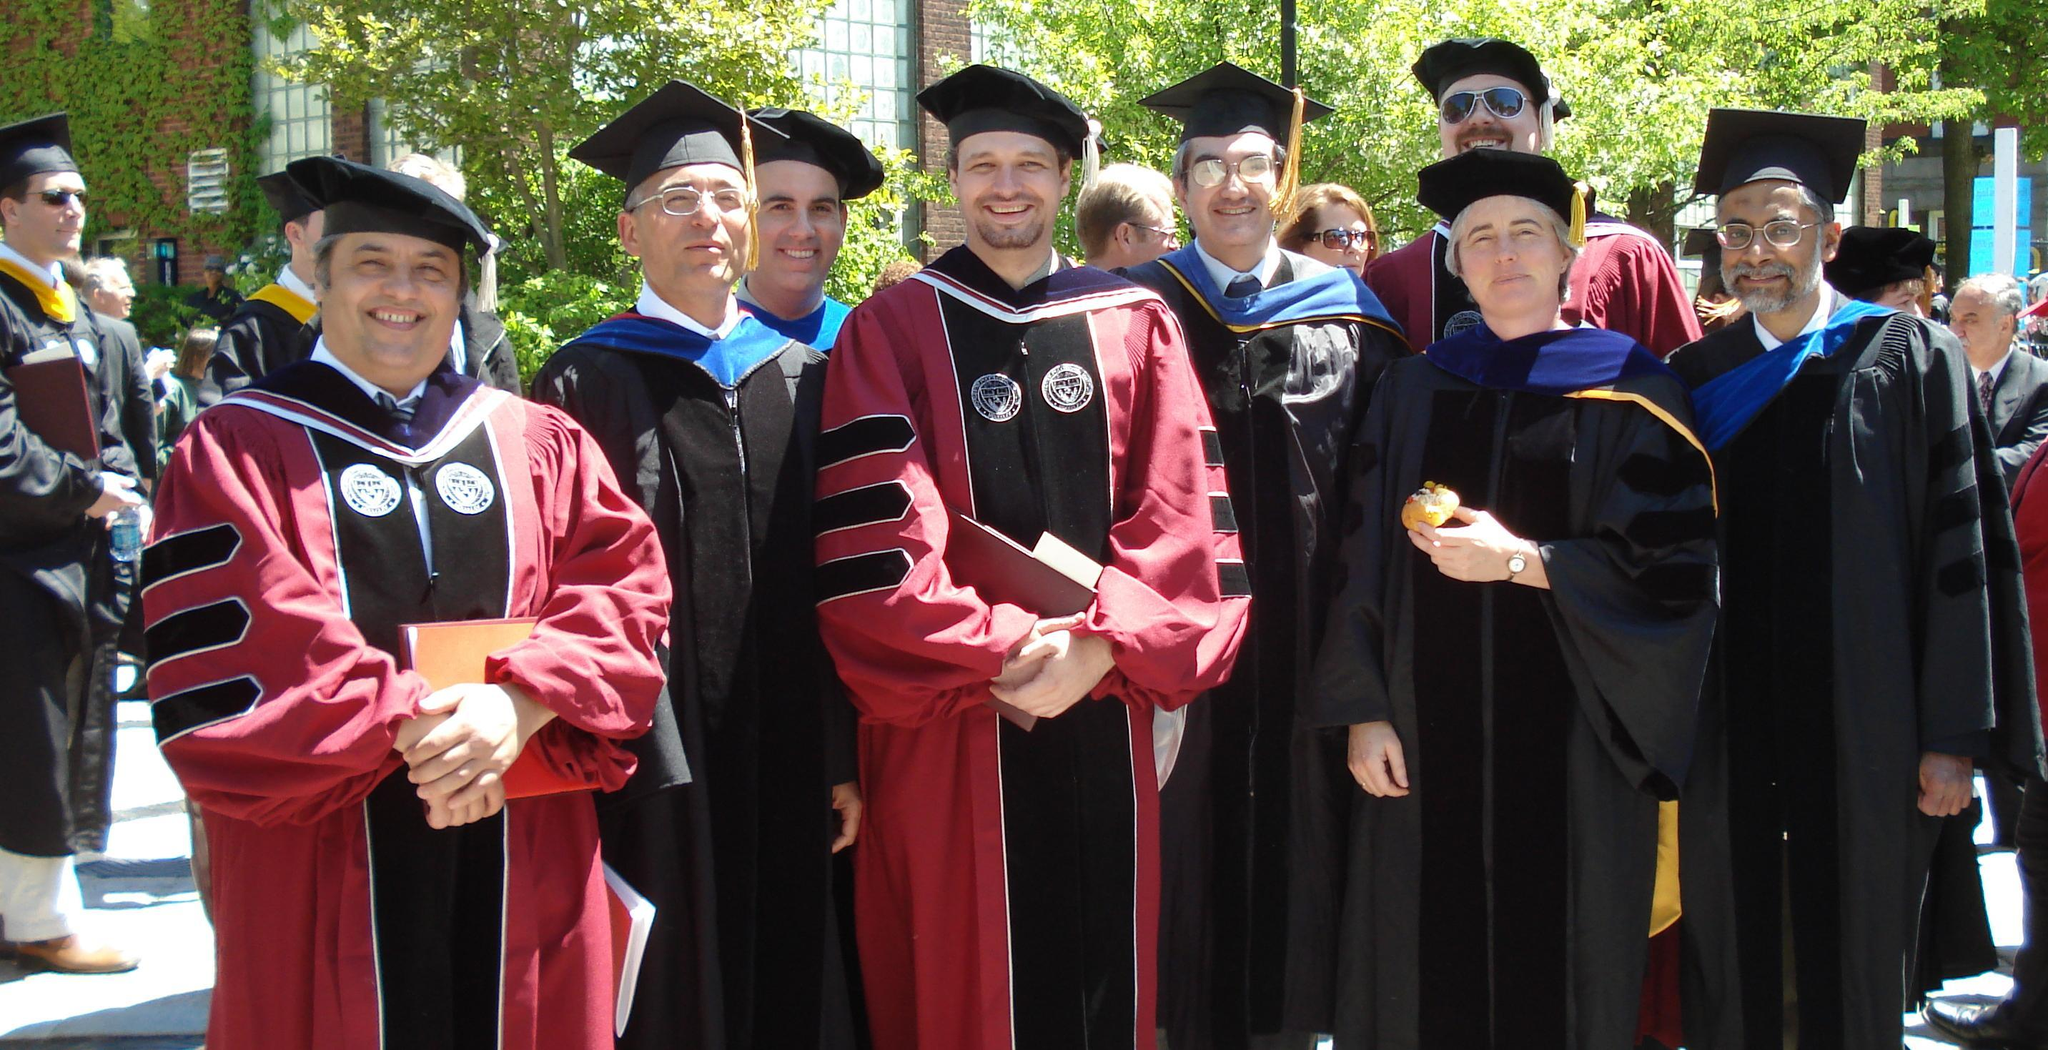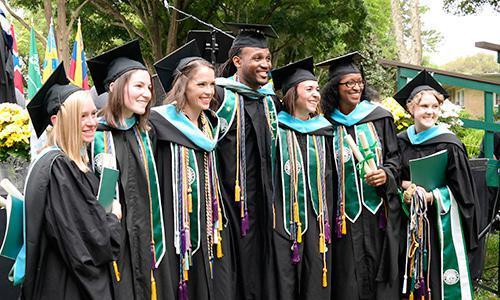The first image is the image on the left, the second image is the image on the right. Evaluate the accuracy of this statement regarding the images: "One image has exactly four people in the foreground.". Is it true? Answer yes or no. No. The first image is the image on the left, the second image is the image on the right. Assess this claim about the two images: "There is a single black male wearing a cap and gowns with a set of tassels hanging down around his neck.". Correct or not? Answer yes or no. Yes. 